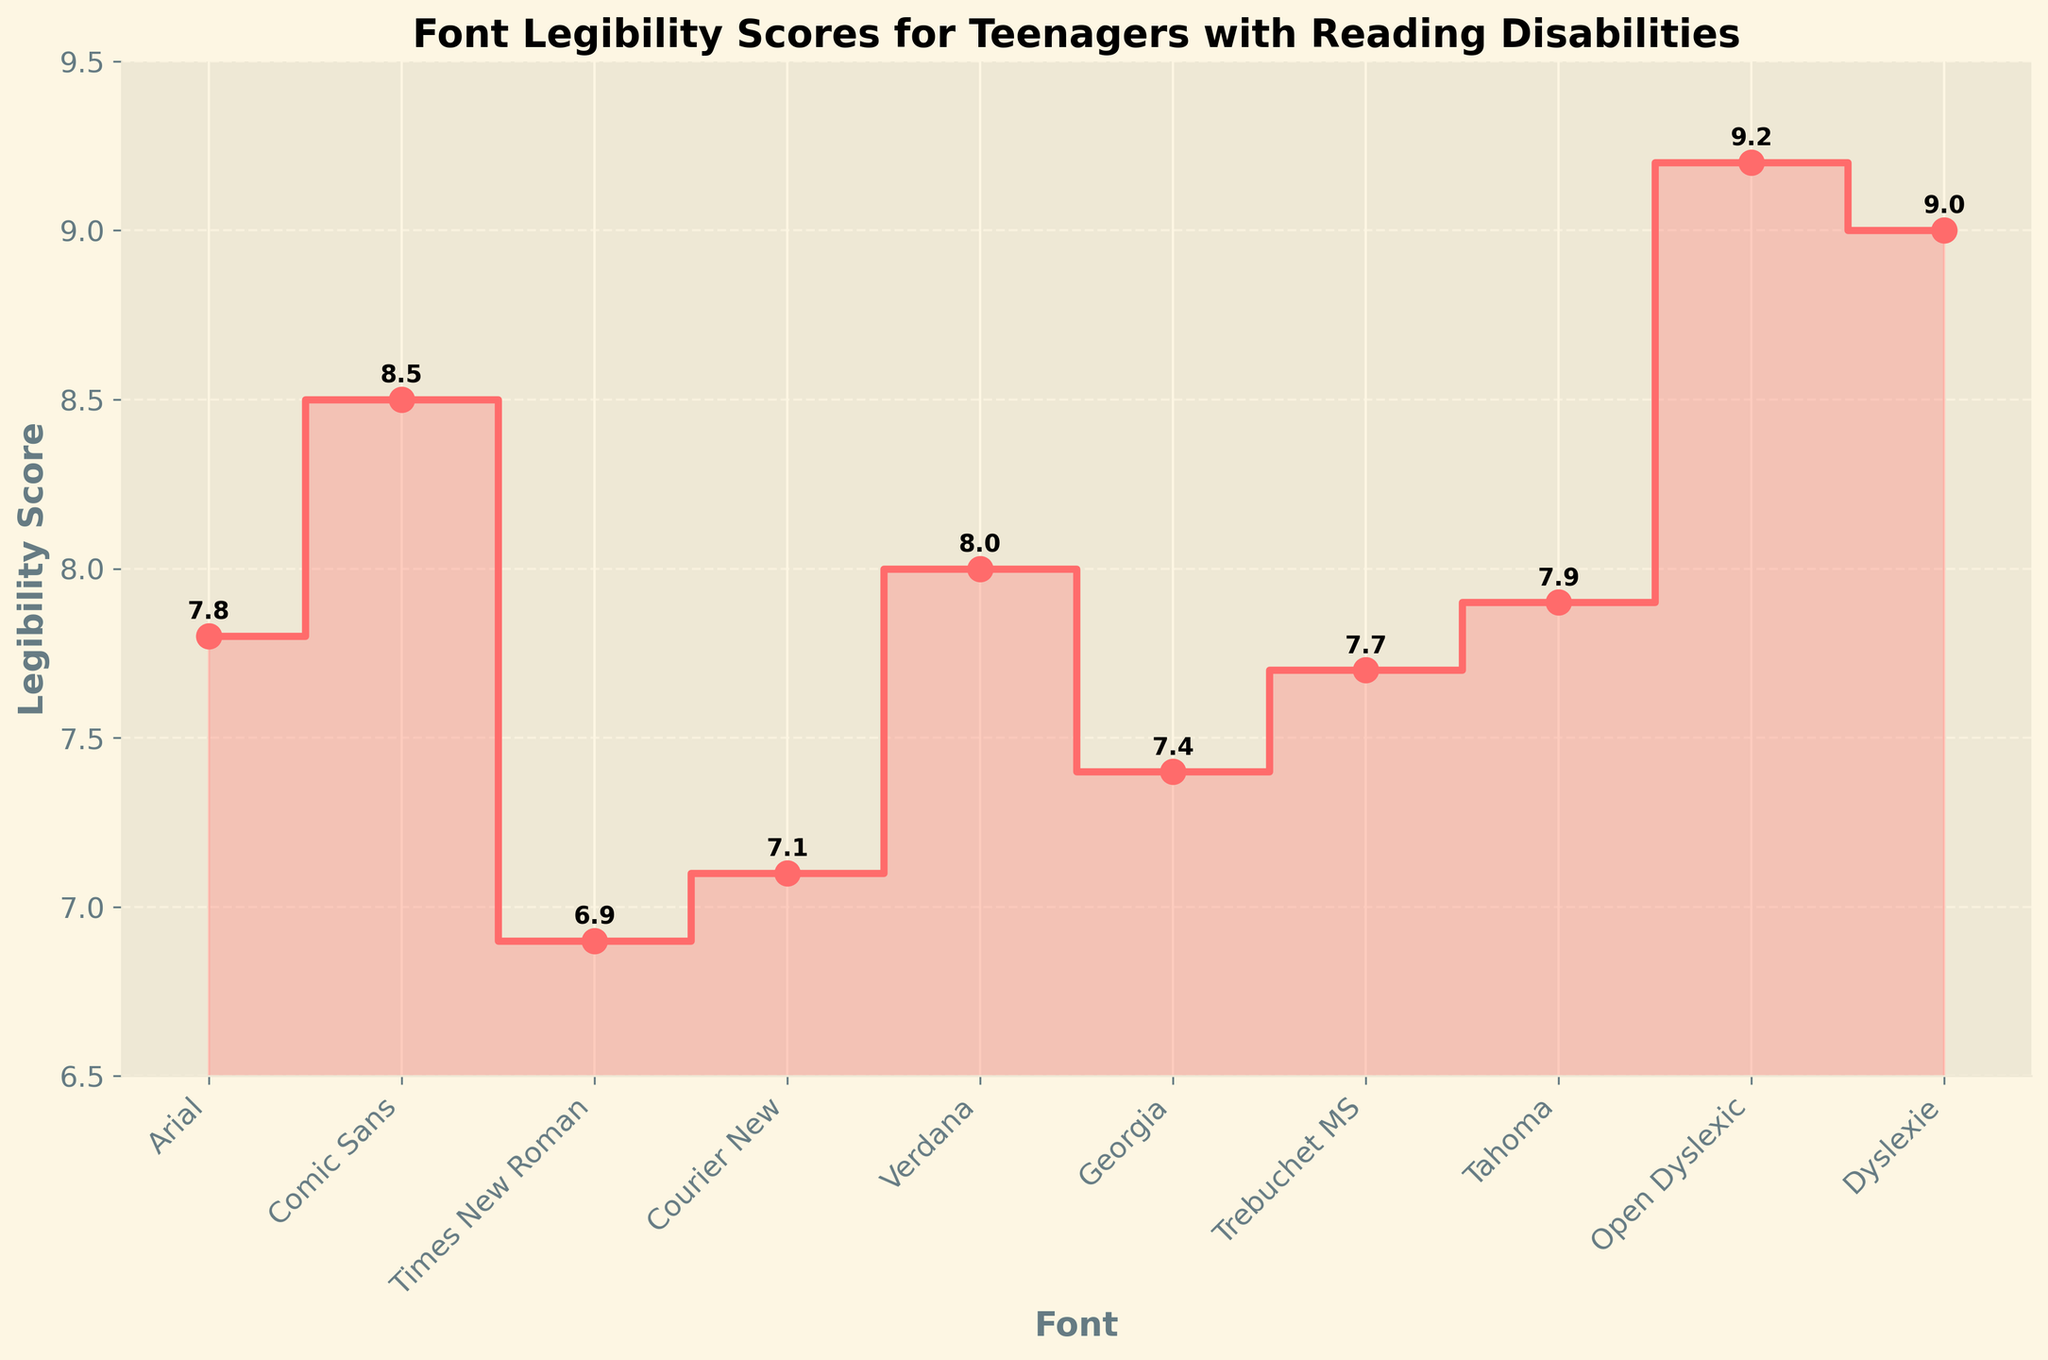What is the legibility score of Comic Sans? The legibility score of Comic Sans is annotated next to the data point on the stair plot.
Answer: 8.5 Which font has the highest legibility score? By checking the highest point on the stair plot, we can see that 'Open Dyslexic' has the highest score.
Answer: Open Dyslexic What is the legibility score range used in the plot? The plot's y-axis ranges from 6.5 to 9.5, which is the legibility score range.
Answer: 6.5 to 9.5 How many fonts have a legibility score of 8 or higher? Examining the plot, we see that Comic Sans, Verdana, Tahoma, Open Dyslexic, and Dyslexie have scores of 8 or higher.
Answer: 5 fonts Which font scored higher, Courier New or Georgia? By comparing the points on the plot, we can see that Georgia has a score of 7.4, whereas Courier New has a score of 7.1.
Answer: Georgia What is the average legibility score of all the fonts combined? Summing all the legibility scores ((7.8 + 8.5 + 6.9 + 7.1 + 8.0 + 7.4 + 7.7 + 7.9 + 9.2 + 9.0) = 79.5) and dividing by the number of fonts (10), we get 79.5/10.
Answer: 7.95 How does Tahoma rank among all fonts in terms of legibility score? Sorting the fonts by their legibility scores, Tahoma with a score of 7.9 ranks fifth.
Answer: Fifth What is the difference in legibility scores between Arial and Times New Roman? Arial has a score of 7.8 and Times New Roman has a score of 6.9. Subtracting these gives 7.8 - 6.9.
Answer: 0.9 Which font has a lower legibility score, Trebuchet MS or Verdana? By examining the stair plot, Trebuchet MS has a score of 7.7 and Verdana has a score of 8.0, making Trebuchet MS lower.
Answer: Trebuchet MS List the fonts in descending order of their legibility scores. By observing the plot and annotating the scores, the fonts in descending order are: Open Dyslexic (9.2), Dyslexie (9.0), Comic Sans (8.5), Verdana (8.0), Tahoma (7.9), Arial (7.8), Trebuchet MS (7.7), Georgia (7.4), Courier New (7.1), Times New Roman (6.9).
Answer: Open Dyslexic, Dyslexie, Comic Sans, Verdana, Tahoma, Arial, Trebuchet MS, Georgia, Courier New, Times New Roman 